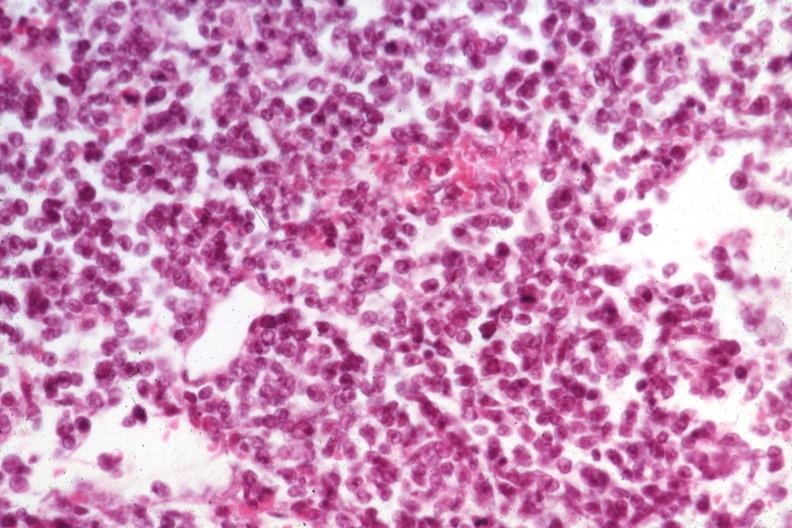what is present?
Answer the question using a single word or phrase. Malignant lymphoma 